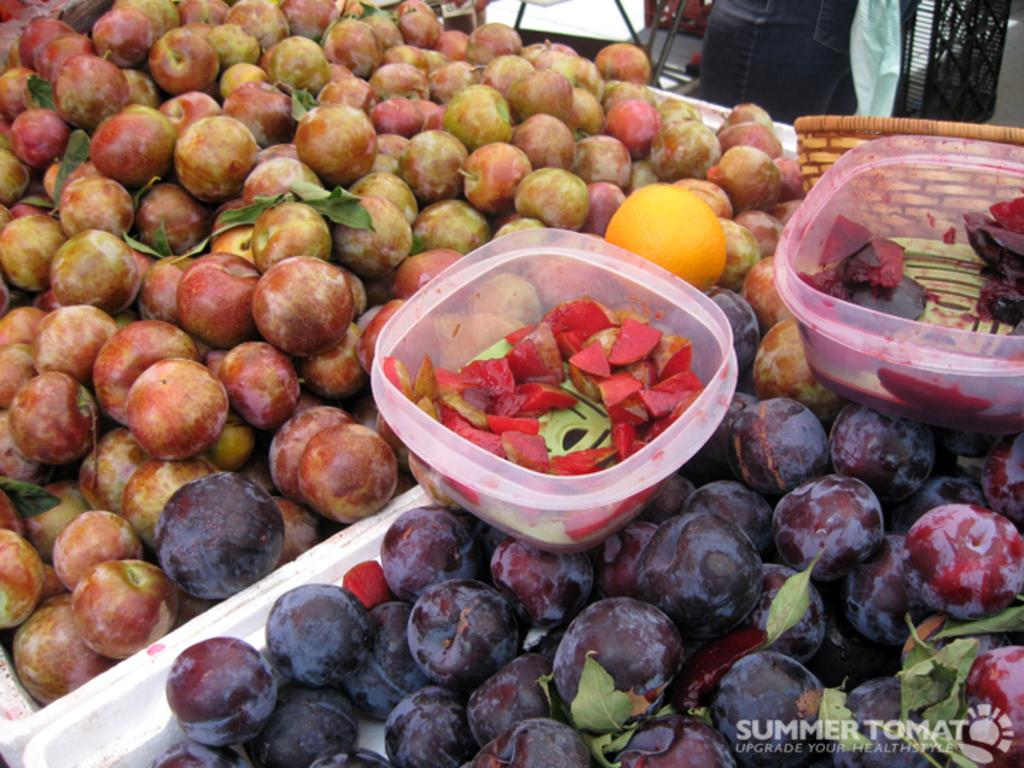What is the main subject in the center of the image? There are fruits in the center of the image. What color are the stands visible at the top of the image? The stands at the top of the image are black. Can you identify any body parts of a person in the image? Yes, the leg of a person is visible in the image. What is the argument about in the image? There is no argument present in the image. Can you describe the type of boot worn by the person in the image? There is no boot visible in the image; only a leg is visible. 